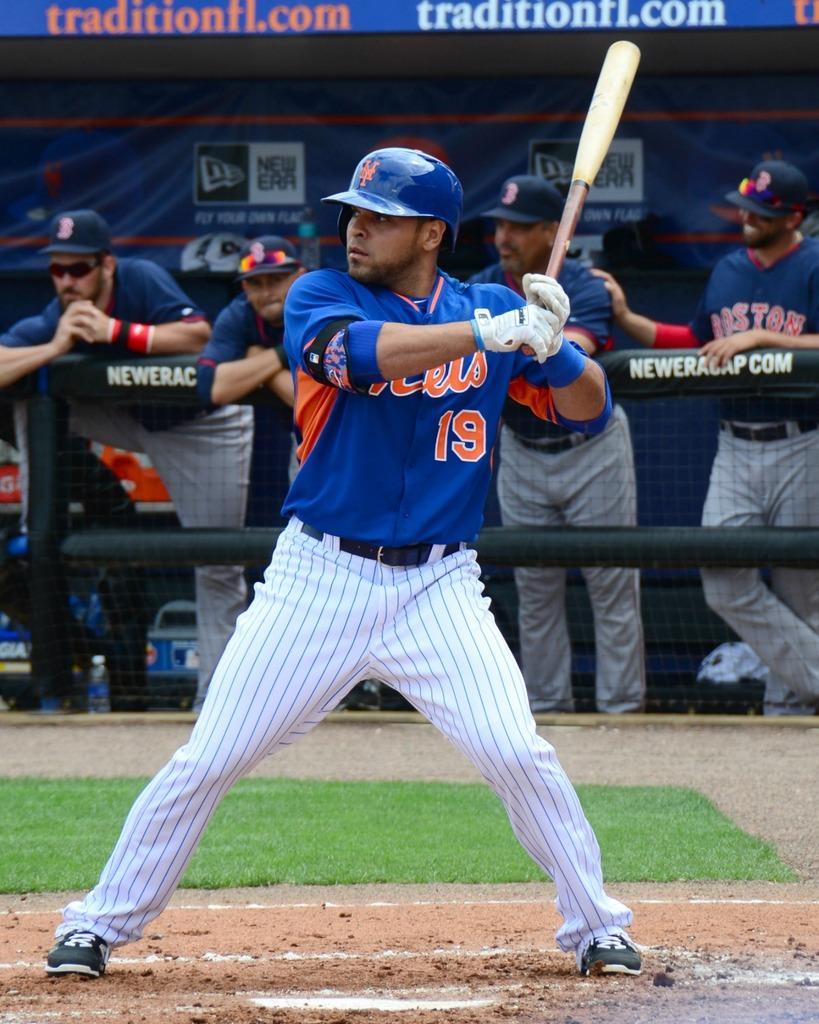<image>
Relay a brief, clear account of the picture shown. A baseball player is up to bat and his teammates are watching from the dug out which says Neweracap.com. 